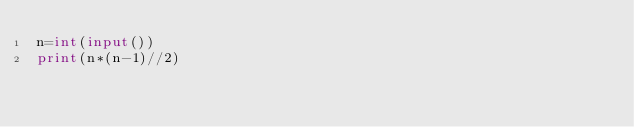<code> <loc_0><loc_0><loc_500><loc_500><_Python_>n=int(input())
print(n*(n-1)//2)</code> 